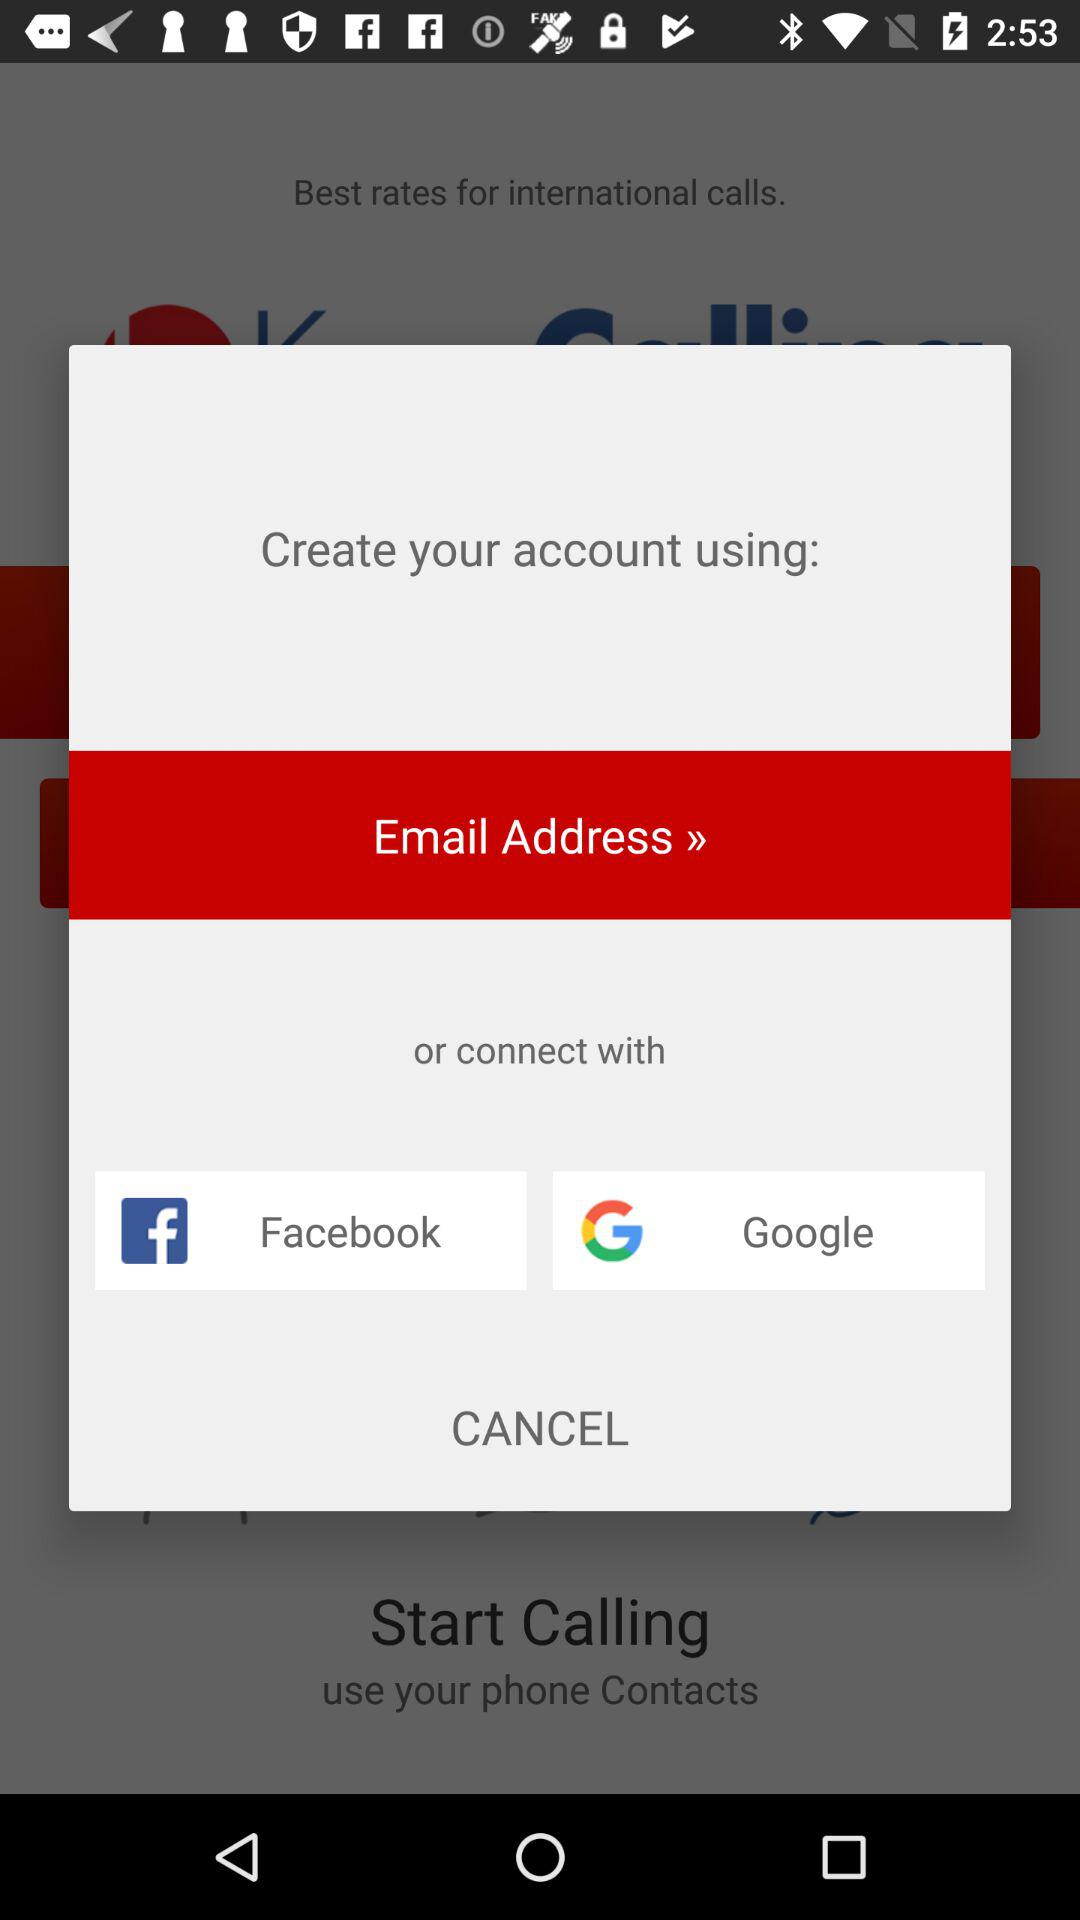Which options are given to create or connect with? The options are "Email Address", "Facebook" and "Google". 